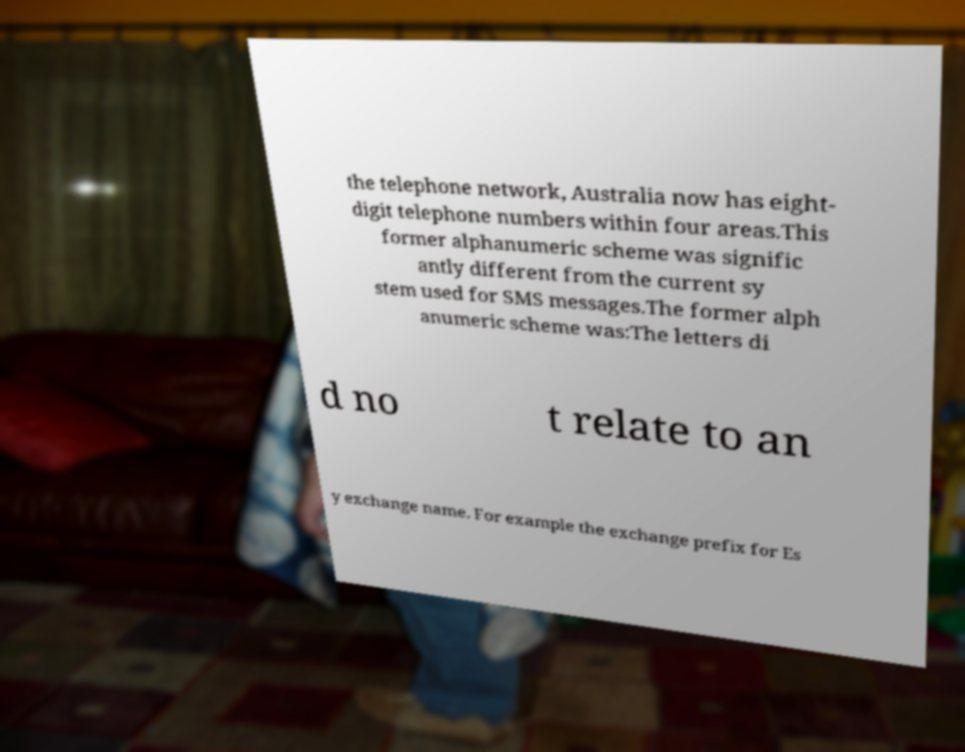Please read and relay the text visible in this image. What does it say? the telephone network, Australia now has eight- digit telephone numbers within four areas.This former alphanumeric scheme was signific antly different from the current sy stem used for SMS messages.The former alph anumeric scheme was:The letters di d no t relate to an y exchange name. For example the exchange prefix for Es 